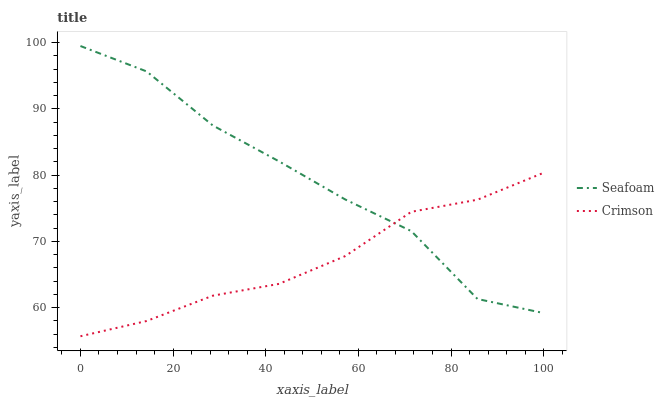Does Crimson have the minimum area under the curve?
Answer yes or no. Yes. Does Seafoam have the maximum area under the curve?
Answer yes or no. Yes. Does Seafoam have the minimum area under the curve?
Answer yes or no. No. Is Crimson the smoothest?
Answer yes or no. Yes. Is Seafoam the roughest?
Answer yes or no. Yes. Is Seafoam the smoothest?
Answer yes or no. No. Does Crimson have the lowest value?
Answer yes or no. Yes. Does Seafoam have the lowest value?
Answer yes or no. No. Does Seafoam have the highest value?
Answer yes or no. Yes. Does Seafoam intersect Crimson?
Answer yes or no. Yes. Is Seafoam less than Crimson?
Answer yes or no. No. Is Seafoam greater than Crimson?
Answer yes or no. No. 